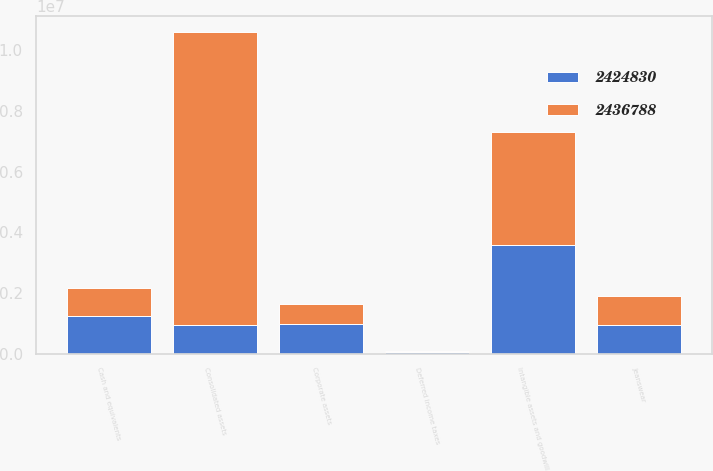Convert chart to OTSL. <chart><loc_0><loc_0><loc_500><loc_500><stacked_bar_chart><ecel><fcel>Jeanswear<fcel>Cash and equivalents<fcel>Intangible assets and goodwill<fcel>Deferred income taxes<fcel>Corporate assets<fcel>Consolidated assets<nl><fcel>2.42483e+06<fcel>943764<fcel>1.22786e+06<fcel>3.57666e+06<fcel>42231<fcel>974652<fcel>951411<nl><fcel>2.43679e+06<fcel>951411<fcel>944423<fcel>3.73702e+06<fcel>39246<fcel>661767<fcel>9.63954e+06<nl></chart> 